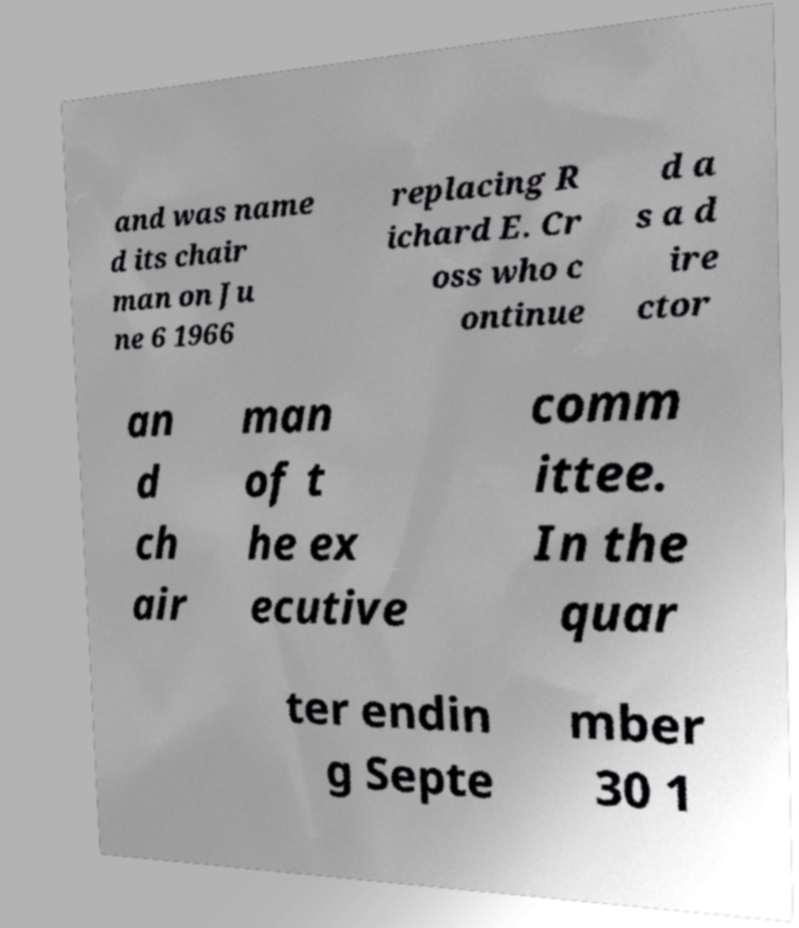Can you accurately transcribe the text from the provided image for me? and was name d its chair man on Ju ne 6 1966 replacing R ichard E. Cr oss who c ontinue d a s a d ire ctor an d ch air man of t he ex ecutive comm ittee. In the quar ter endin g Septe mber 30 1 